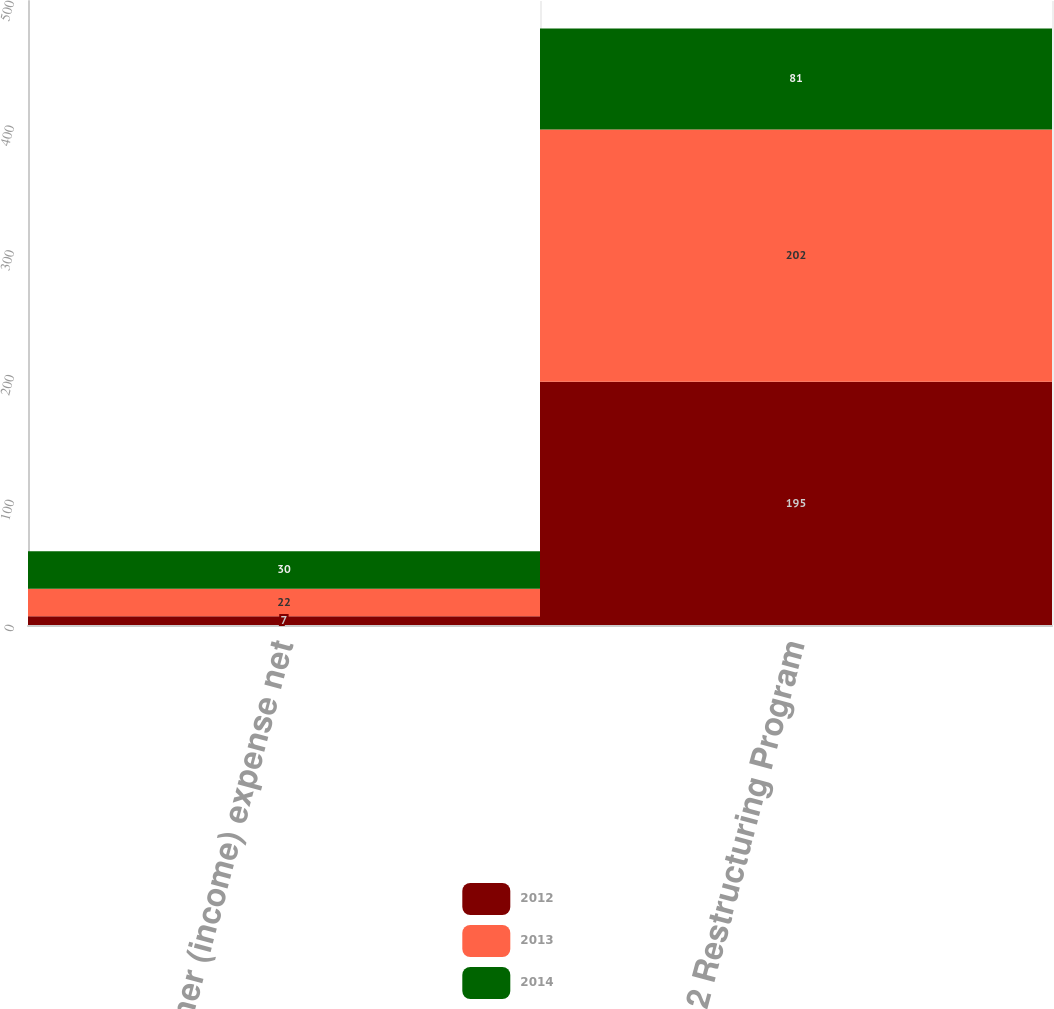Convert chart. <chart><loc_0><loc_0><loc_500><loc_500><stacked_bar_chart><ecel><fcel>Other (income) expense net<fcel>2012 Restructuring Program<nl><fcel>2012<fcel>7<fcel>195<nl><fcel>2013<fcel>22<fcel>202<nl><fcel>2014<fcel>30<fcel>81<nl></chart> 